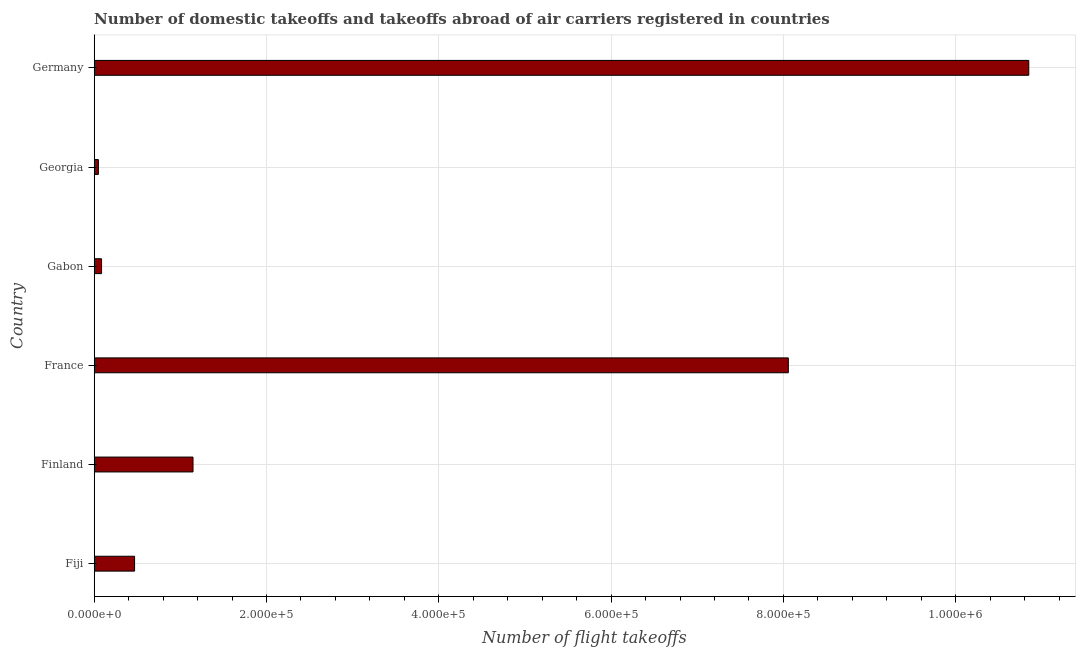Does the graph contain any zero values?
Provide a short and direct response. No. What is the title of the graph?
Keep it short and to the point. Number of domestic takeoffs and takeoffs abroad of air carriers registered in countries. What is the label or title of the X-axis?
Your response must be concise. Number of flight takeoffs. What is the number of flight takeoffs in Fiji?
Your answer should be compact. 4.69e+04. Across all countries, what is the maximum number of flight takeoffs?
Provide a short and direct response. 1.08e+06. Across all countries, what is the minimum number of flight takeoffs?
Your answer should be compact. 4861. In which country was the number of flight takeoffs maximum?
Ensure brevity in your answer.  Germany. In which country was the number of flight takeoffs minimum?
Provide a succinct answer. Georgia. What is the sum of the number of flight takeoffs?
Provide a succinct answer. 2.07e+06. What is the difference between the number of flight takeoffs in Gabon and Georgia?
Ensure brevity in your answer.  3663. What is the average number of flight takeoffs per country?
Your answer should be compact. 3.44e+05. What is the median number of flight takeoffs?
Keep it short and to the point. 8.08e+04. What is the ratio of the number of flight takeoffs in Gabon to that in Germany?
Your answer should be compact. 0.01. What is the difference between the highest and the second highest number of flight takeoffs?
Your answer should be very brief. 2.79e+05. What is the difference between the highest and the lowest number of flight takeoffs?
Provide a short and direct response. 1.08e+06. In how many countries, is the number of flight takeoffs greater than the average number of flight takeoffs taken over all countries?
Your response must be concise. 2. What is the difference between two consecutive major ticks on the X-axis?
Your response must be concise. 2.00e+05. What is the Number of flight takeoffs in Fiji?
Offer a very short reply. 4.69e+04. What is the Number of flight takeoffs in Finland?
Your answer should be very brief. 1.15e+05. What is the Number of flight takeoffs of France?
Your answer should be very brief. 8.06e+05. What is the Number of flight takeoffs of Gabon?
Ensure brevity in your answer.  8524. What is the Number of flight takeoffs of Georgia?
Make the answer very short. 4861. What is the Number of flight takeoffs of Germany?
Give a very brief answer. 1.08e+06. What is the difference between the Number of flight takeoffs in Fiji and Finland?
Offer a terse response. -6.78e+04. What is the difference between the Number of flight takeoffs in Fiji and France?
Keep it short and to the point. -7.59e+05. What is the difference between the Number of flight takeoffs in Fiji and Gabon?
Provide a succinct answer. 3.83e+04. What is the difference between the Number of flight takeoffs in Fiji and Georgia?
Provide a succinct answer. 4.20e+04. What is the difference between the Number of flight takeoffs in Fiji and Germany?
Keep it short and to the point. -1.04e+06. What is the difference between the Number of flight takeoffs in Finland and France?
Your answer should be very brief. -6.91e+05. What is the difference between the Number of flight takeoffs in Finland and Gabon?
Provide a succinct answer. 1.06e+05. What is the difference between the Number of flight takeoffs in Finland and Georgia?
Make the answer very short. 1.10e+05. What is the difference between the Number of flight takeoffs in Finland and Germany?
Offer a terse response. -9.70e+05. What is the difference between the Number of flight takeoffs in France and Gabon?
Provide a short and direct response. 7.97e+05. What is the difference between the Number of flight takeoffs in France and Georgia?
Provide a short and direct response. 8.01e+05. What is the difference between the Number of flight takeoffs in France and Germany?
Offer a terse response. -2.79e+05. What is the difference between the Number of flight takeoffs in Gabon and Georgia?
Ensure brevity in your answer.  3663. What is the difference between the Number of flight takeoffs in Gabon and Germany?
Your response must be concise. -1.08e+06. What is the difference between the Number of flight takeoffs in Georgia and Germany?
Your answer should be very brief. -1.08e+06. What is the ratio of the Number of flight takeoffs in Fiji to that in Finland?
Make the answer very short. 0.41. What is the ratio of the Number of flight takeoffs in Fiji to that in France?
Keep it short and to the point. 0.06. What is the ratio of the Number of flight takeoffs in Fiji to that in Gabon?
Make the answer very short. 5.5. What is the ratio of the Number of flight takeoffs in Fiji to that in Georgia?
Your response must be concise. 9.64. What is the ratio of the Number of flight takeoffs in Fiji to that in Germany?
Offer a terse response. 0.04. What is the ratio of the Number of flight takeoffs in Finland to that in France?
Your answer should be very brief. 0.14. What is the ratio of the Number of flight takeoffs in Finland to that in Gabon?
Make the answer very short. 13.46. What is the ratio of the Number of flight takeoffs in Finland to that in Georgia?
Provide a short and direct response. 23.6. What is the ratio of the Number of flight takeoffs in Finland to that in Germany?
Offer a terse response. 0.11. What is the ratio of the Number of flight takeoffs in France to that in Gabon?
Make the answer very short. 94.53. What is the ratio of the Number of flight takeoffs in France to that in Georgia?
Your answer should be compact. 165.75. What is the ratio of the Number of flight takeoffs in France to that in Germany?
Provide a short and direct response. 0.74. What is the ratio of the Number of flight takeoffs in Gabon to that in Georgia?
Provide a short and direct response. 1.75. What is the ratio of the Number of flight takeoffs in Gabon to that in Germany?
Your response must be concise. 0.01. What is the ratio of the Number of flight takeoffs in Georgia to that in Germany?
Provide a short and direct response. 0. 